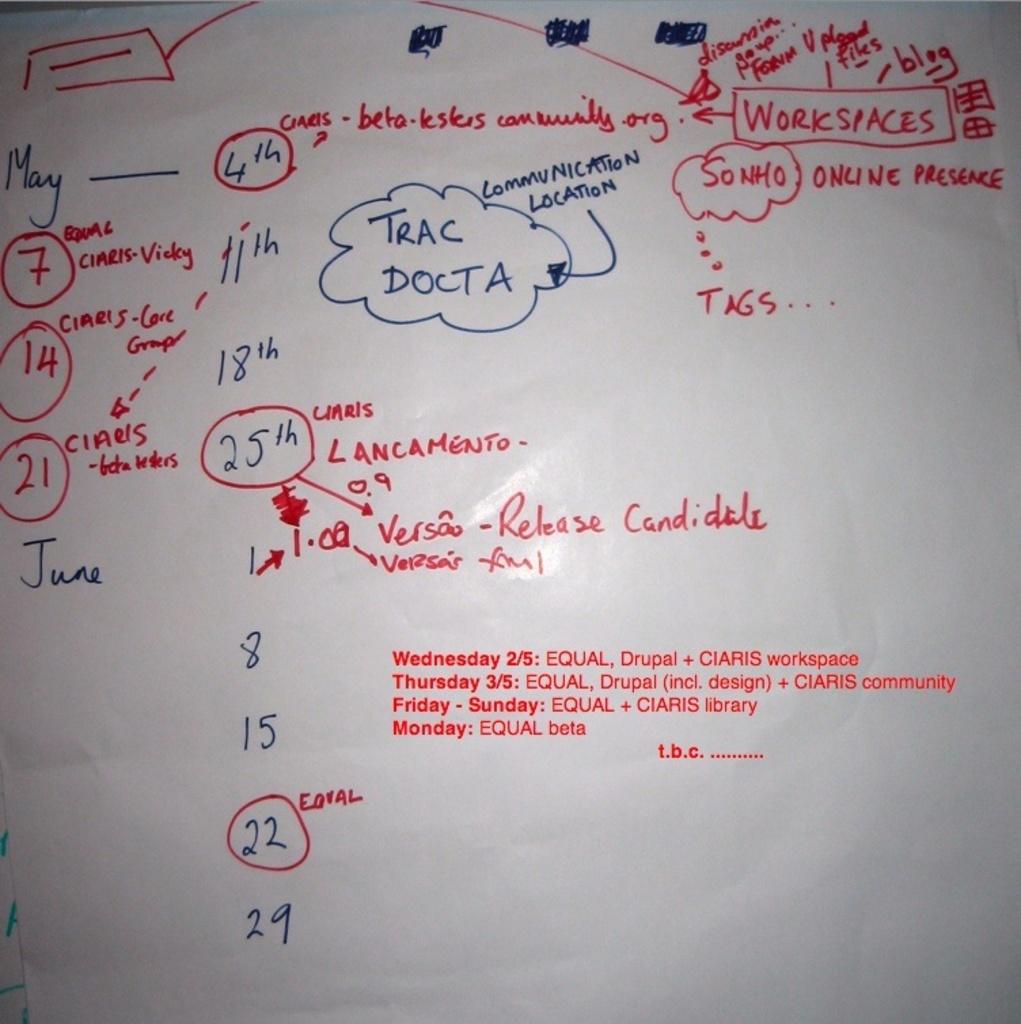What is the topic of these notes?
Provide a succinct answer. Workspaces. What is written above docta in the middle?
Give a very brief answer. Trac. 